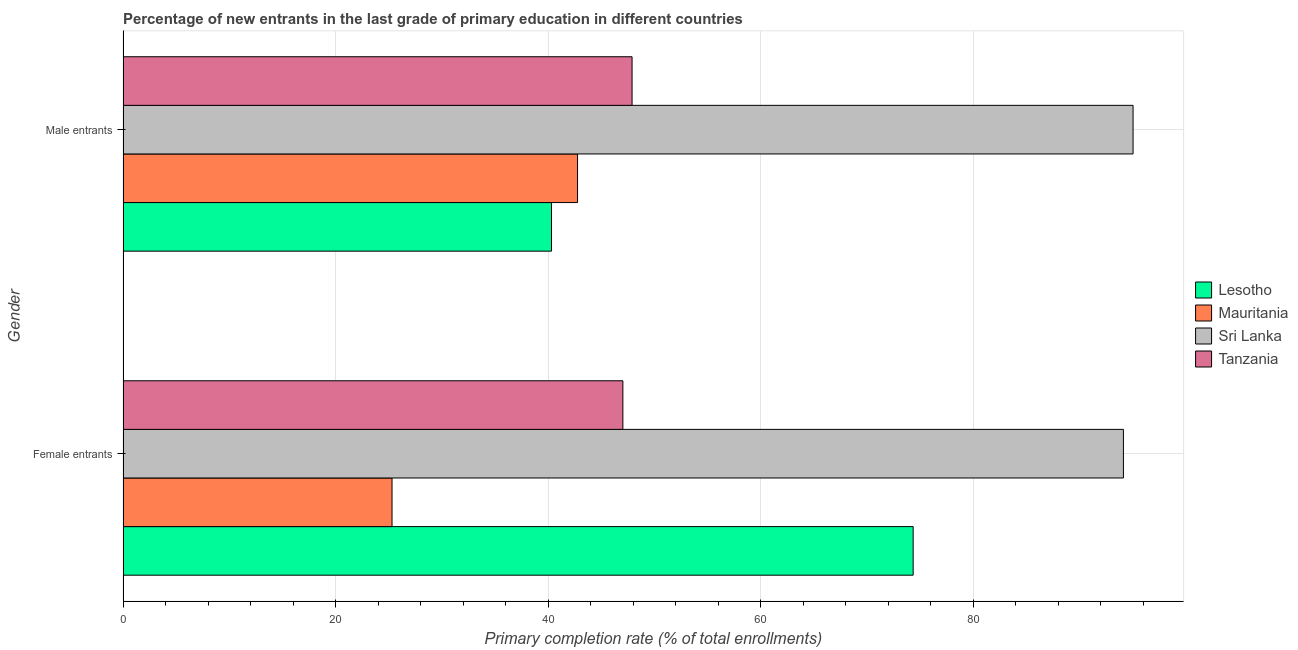How many groups of bars are there?
Your response must be concise. 2. Are the number of bars per tick equal to the number of legend labels?
Offer a very short reply. Yes. Are the number of bars on each tick of the Y-axis equal?
Offer a terse response. Yes. How many bars are there on the 2nd tick from the top?
Ensure brevity in your answer.  4. What is the label of the 2nd group of bars from the top?
Keep it short and to the point. Female entrants. What is the primary completion rate of female entrants in Mauritania?
Your answer should be compact. 25.32. Across all countries, what is the maximum primary completion rate of female entrants?
Give a very brief answer. 94.16. Across all countries, what is the minimum primary completion rate of female entrants?
Offer a very short reply. 25.32. In which country was the primary completion rate of female entrants maximum?
Provide a short and direct response. Sri Lanka. In which country was the primary completion rate of female entrants minimum?
Your response must be concise. Mauritania. What is the total primary completion rate of female entrants in the graph?
Provide a short and direct response. 240.89. What is the difference between the primary completion rate of female entrants in Tanzania and that in Mauritania?
Provide a succinct answer. 21.73. What is the difference between the primary completion rate of female entrants in Sri Lanka and the primary completion rate of male entrants in Lesotho?
Keep it short and to the point. 53.83. What is the average primary completion rate of male entrants per country?
Offer a terse response. 56.52. What is the difference between the primary completion rate of male entrants and primary completion rate of female entrants in Sri Lanka?
Your response must be concise. 0.91. What is the ratio of the primary completion rate of female entrants in Mauritania to that in Tanzania?
Give a very brief answer. 0.54. In how many countries, is the primary completion rate of female entrants greater than the average primary completion rate of female entrants taken over all countries?
Make the answer very short. 2. What does the 4th bar from the top in Female entrants represents?
Give a very brief answer. Lesotho. What does the 4th bar from the bottom in Female entrants represents?
Offer a terse response. Tanzania. How many bars are there?
Your response must be concise. 8. What is the difference between two consecutive major ticks on the X-axis?
Make the answer very short. 20. Are the values on the major ticks of X-axis written in scientific E-notation?
Keep it short and to the point. No. Does the graph contain grids?
Your answer should be compact. Yes. Where does the legend appear in the graph?
Provide a short and direct response. Center right. How many legend labels are there?
Your answer should be very brief. 4. How are the legend labels stacked?
Ensure brevity in your answer.  Vertical. What is the title of the graph?
Ensure brevity in your answer.  Percentage of new entrants in the last grade of primary education in different countries. What is the label or title of the X-axis?
Give a very brief answer. Primary completion rate (% of total enrollments). What is the Primary completion rate (% of total enrollments) in Lesotho in Female entrants?
Offer a very short reply. 74.37. What is the Primary completion rate (% of total enrollments) of Mauritania in Female entrants?
Offer a terse response. 25.32. What is the Primary completion rate (% of total enrollments) of Sri Lanka in Female entrants?
Your response must be concise. 94.16. What is the Primary completion rate (% of total enrollments) of Tanzania in Female entrants?
Make the answer very short. 47.05. What is the Primary completion rate (% of total enrollments) of Lesotho in Male entrants?
Make the answer very short. 40.33. What is the Primary completion rate (% of total enrollments) in Mauritania in Male entrants?
Ensure brevity in your answer.  42.78. What is the Primary completion rate (% of total enrollments) in Sri Lanka in Male entrants?
Provide a succinct answer. 95.06. What is the Primary completion rate (% of total enrollments) of Tanzania in Male entrants?
Your answer should be very brief. 47.91. Across all Gender, what is the maximum Primary completion rate (% of total enrollments) in Lesotho?
Give a very brief answer. 74.37. Across all Gender, what is the maximum Primary completion rate (% of total enrollments) of Mauritania?
Offer a very short reply. 42.78. Across all Gender, what is the maximum Primary completion rate (% of total enrollments) of Sri Lanka?
Your answer should be very brief. 95.06. Across all Gender, what is the maximum Primary completion rate (% of total enrollments) of Tanzania?
Ensure brevity in your answer.  47.91. Across all Gender, what is the minimum Primary completion rate (% of total enrollments) in Lesotho?
Ensure brevity in your answer.  40.33. Across all Gender, what is the minimum Primary completion rate (% of total enrollments) in Mauritania?
Your response must be concise. 25.32. Across all Gender, what is the minimum Primary completion rate (% of total enrollments) of Sri Lanka?
Ensure brevity in your answer.  94.16. Across all Gender, what is the minimum Primary completion rate (% of total enrollments) in Tanzania?
Your response must be concise. 47.05. What is the total Primary completion rate (% of total enrollments) in Lesotho in the graph?
Give a very brief answer. 114.69. What is the total Primary completion rate (% of total enrollments) in Mauritania in the graph?
Ensure brevity in your answer.  68.1. What is the total Primary completion rate (% of total enrollments) in Sri Lanka in the graph?
Provide a short and direct response. 189.22. What is the total Primary completion rate (% of total enrollments) of Tanzania in the graph?
Make the answer very short. 94.96. What is the difference between the Primary completion rate (% of total enrollments) of Lesotho in Female entrants and that in Male entrants?
Keep it short and to the point. 34.04. What is the difference between the Primary completion rate (% of total enrollments) of Mauritania in Female entrants and that in Male entrants?
Your response must be concise. -17.46. What is the difference between the Primary completion rate (% of total enrollments) of Sri Lanka in Female entrants and that in Male entrants?
Keep it short and to the point. -0.91. What is the difference between the Primary completion rate (% of total enrollments) of Tanzania in Female entrants and that in Male entrants?
Keep it short and to the point. -0.87. What is the difference between the Primary completion rate (% of total enrollments) of Lesotho in Female entrants and the Primary completion rate (% of total enrollments) of Mauritania in Male entrants?
Keep it short and to the point. 31.59. What is the difference between the Primary completion rate (% of total enrollments) of Lesotho in Female entrants and the Primary completion rate (% of total enrollments) of Sri Lanka in Male entrants?
Your response must be concise. -20.7. What is the difference between the Primary completion rate (% of total enrollments) of Lesotho in Female entrants and the Primary completion rate (% of total enrollments) of Tanzania in Male entrants?
Your answer should be very brief. 26.45. What is the difference between the Primary completion rate (% of total enrollments) in Mauritania in Female entrants and the Primary completion rate (% of total enrollments) in Sri Lanka in Male entrants?
Your answer should be compact. -69.74. What is the difference between the Primary completion rate (% of total enrollments) of Mauritania in Female entrants and the Primary completion rate (% of total enrollments) of Tanzania in Male entrants?
Provide a succinct answer. -22.59. What is the difference between the Primary completion rate (% of total enrollments) of Sri Lanka in Female entrants and the Primary completion rate (% of total enrollments) of Tanzania in Male entrants?
Keep it short and to the point. 46.24. What is the average Primary completion rate (% of total enrollments) of Lesotho per Gender?
Provide a succinct answer. 57.35. What is the average Primary completion rate (% of total enrollments) in Mauritania per Gender?
Your answer should be compact. 34.05. What is the average Primary completion rate (% of total enrollments) of Sri Lanka per Gender?
Your response must be concise. 94.61. What is the average Primary completion rate (% of total enrollments) of Tanzania per Gender?
Offer a terse response. 47.48. What is the difference between the Primary completion rate (% of total enrollments) of Lesotho and Primary completion rate (% of total enrollments) of Mauritania in Female entrants?
Give a very brief answer. 49.05. What is the difference between the Primary completion rate (% of total enrollments) of Lesotho and Primary completion rate (% of total enrollments) of Sri Lanka in Female entrants?
Offer a very short reply. -19.79. What is the difference between the Primary completion rate (% of total enrollments) of Lesotho and Primary completion rate (% of total enrollments) of Tanzania in Female entrants?
Your response must be concise. 27.32. What is the difference between the Primary completion rate (% of total enrollments) in Mauritania and Primary completion rate (% of total enrollments) in Sri Lanka in Female entrants?
Provide a succinct answer. -68.84. What is the difference between the Primary completion rate (% of total enrollments) of Mauritania and Primary completion rate (% of total enrollments) of Tanzania in Female entrants?
Your answer should be compact. -21.73. What is the difference between the Primary completion rate (% of total enrollments) of Sri Lanka and Primary completion rate (% of total enrollments) of Tanzania in Female entrants?
Keep it short and to the point. 47.11. What is the difference between the Primary completion rate (% of total enrollments) of Lesotho and Primary completion rate (% of total enrollments) of Mauritania in Male entrants?
Your answer should be compact. -2.45. What is the difference between the Primary completion rate (% of total enrollments) in Lesotho and Primary completion rate (% of total enrollments) in Sri Lanka in Male entrants?
Keep it short and to the point. -54.74. What is the difference between the Primary completion rate (% of total enrollments) of Lesotho and Primary completion rate (% of total enrollments) of Tanzania in Male entrants?
Offer a terse response. -7.59. What is the difference between the Primary completion rate (% of total enrollments) in Mauritania and Primary completion rate (% of total enrollments) in Sri Lanka in Male entrants?
Provide a short and direct response. -52.28. What is the difference between the Primary completion rate (% of total enrollments) of Mauritania and Primary completion rate (% of total enrollments) of Tanzania in Male entrants?
Your answer should be very brief. -5.13. What is the difference between the Primary completion rate (% of total enrollments) in Sri Lanka and Primary completion rate (% of total enrollments) in Tanzania in Male entrants?
Your answer should be very brief. 47.15. What is the ratio of the Primary completion rate (% of total enrollments) in Lesotho in Female entrants to that in Male entrants?
Give a very brief answer. 1.84. What is the ratio of the Primary completion rate (% of total enrollments) of Mauritania in Female entrants to that in Male entrants?
Your answer should be compact. 0.59. What is the ratio of the Primary completion rate (% of total enrollments) in Sri Lanka in Female entrants to that in Male entrants?
Provide a short and direct response. 0.99. What is the ratio of the Primary completion rate (% of total enrollments) in Tanzania in Female entrants to that in Male entrants?
Your response must be concise. 0.98. What is the difference between the highest and the second highest Primary completion rate (% of total enrollments) of Lesotho?
Provide a short and direct response. 34.04. What is the difference between the highest and the second highest Primary completion rate (% of total enrollments) in Mauritania?
Offer a terse response. 17.46. What is the difference between the highest and the second highest Primary completion rate (% of total enrollments) of Sri Lanka?
Provide a succinct answer. 0.91. What is the difference between the highest and the second highest Primary completion rate (% of total enrollments) of Tanzania?
Ensure brevity in your answer.  0.87. What is the difference between the highest and the lowest Primary completion rate (% of total enrollments) of Lesotho?
Offer a terse response. 34.04. What is the difference between the highest and the lowest Primary completion rate (% of total enrollments) of Mauritania?
Your answer should be compact. 17.46. What is the difference between the highest and the lowest Primary completion rate (% of total enrollments) of Sri Lanka?
Give a very brief answer. 0.91. What is the difference between the highest and the lowest Primary completion rate (% of total enrollments) of Tanzania?
Offer a terse response. 0.87. 